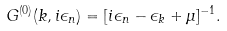Convert formula to latex. <formula><loc_0><loc_0><loc_500><loc_500>G ^ { ( 0 ) } ( k , i \epsilon _ { n } ) = [ i \epsilon _ { n } - \epsilon _ { k } + \mu ] ^ { - 1 } .</formula> 